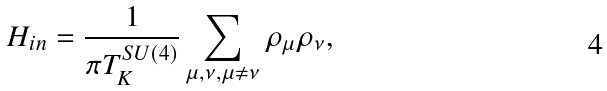Convert formula to latex. <formula><loc_0><loc_0><loc_500><loc_500>H _ { i n } = \frac { 1 } { \pi T _ { K } ^ { S U ( 4 ) } } \sum _ { \mu , \nu , \mu \neq \nu } \rho _ { \mu } \rho _ { \nu } ,</formula> 